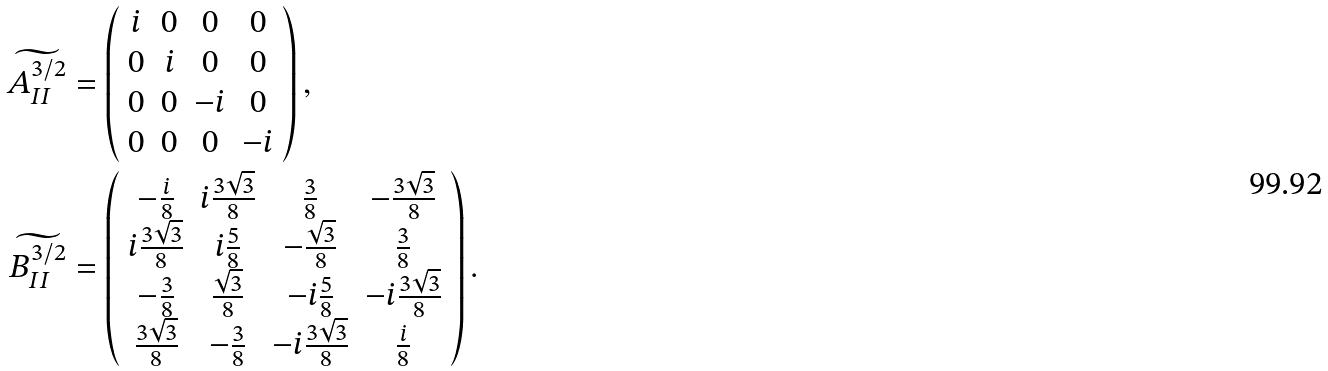<formula> <loc_0><loc_0><loc_500><loc_500>\widetilde { A _ { I I } ^ { 3 / 2 } } & = \left ( \begin{array} { c c c c } i & 0 & 0 & 0 \\ 0 & i & 0 & 0 \\ 0 & 0 & - i & 0 \\ 0 & 0 & 0 & - i \end{array} \right ) , \\ \widetilde { B _ { I I } ^ { 3 / 2 } } & = \left ( \begin{array} { c c c c } - \frac { i } { 8 } & i \frac { 3 \sqrt { 3 } } { 8 } & \frac { 3 } { 8 } & - \frac { 3 \sqrt { 3 } } { 8 } \\ i \frac { 3 \sqrt { 3 } } { 8 } & i \frac { 5 } { 8 } & - \frac { \sqrt { 3 } } { 8 } & \frac { 3 } { 8 } \\ - \frac { 3 } { 8 } & \frac { \sqrt { 3 } } { 8 } & - i \frac { 5 } { 8 } & - i \frac { 3 \sqrt { 3 } } { 8 } \\ \frac { 3 \sqrt { 3 } } { 8 } & - \frac { 3 } { 8 } & - i \frac { 3 \sqrt { 3 } } { 8 } & \frac { i } { 8 } \end{array} \right ) .</formula> 